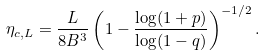Convert formula to latex. <formula><loc_0><loc_0><loc_500><loc_500>\eta _ { c , L } = \frac { L } { 8 B ^ { 3 } } \left ( 1 - \frac { \log ( 1 + p ) } { \log ( 1 - q ) } \right ) ^ { - 1 / 2 } .</formula> 